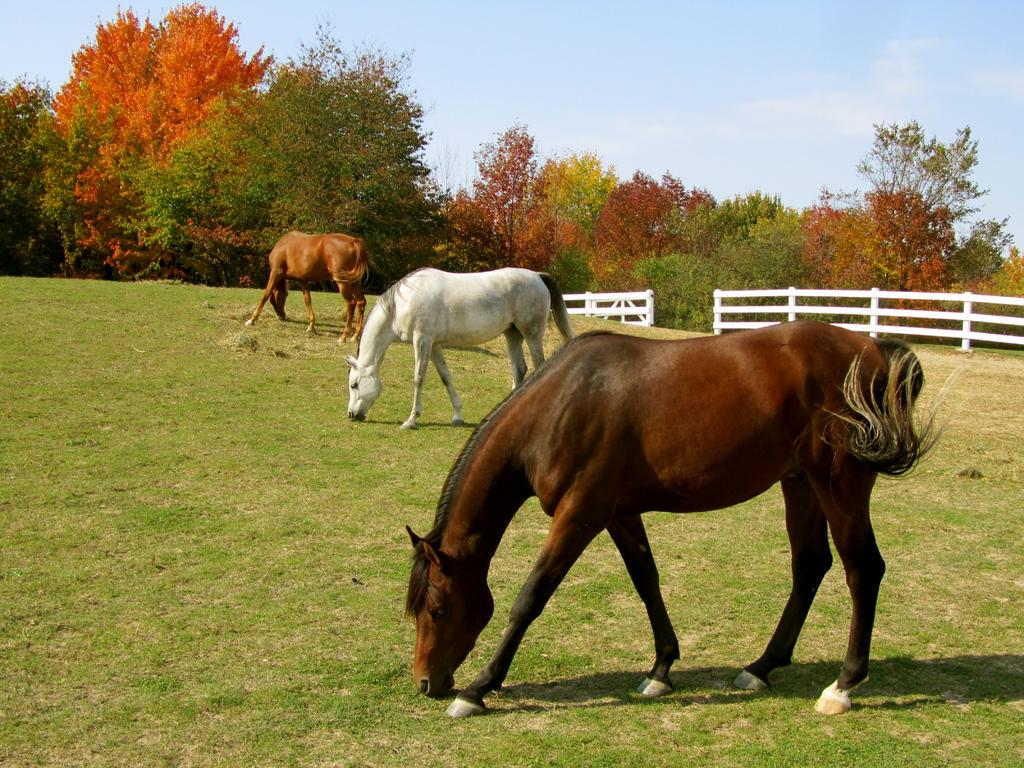How many horses are in the image? There are three horses in the image. What are the horses doing in the image? The horses are eating grass in the image. What type of vegetation can be seen in the image? There is grass visible in the image. What type of barrier is present in the image? There is a wooden fence in the image. What else can be seen in the background of the image? There are trees and the sky visible in the image. Where is the grandmother sitting in the image? There is no grandmother present in the image. What type of wrist support is visible in the image? There is: There is no wrist support present in the image. 